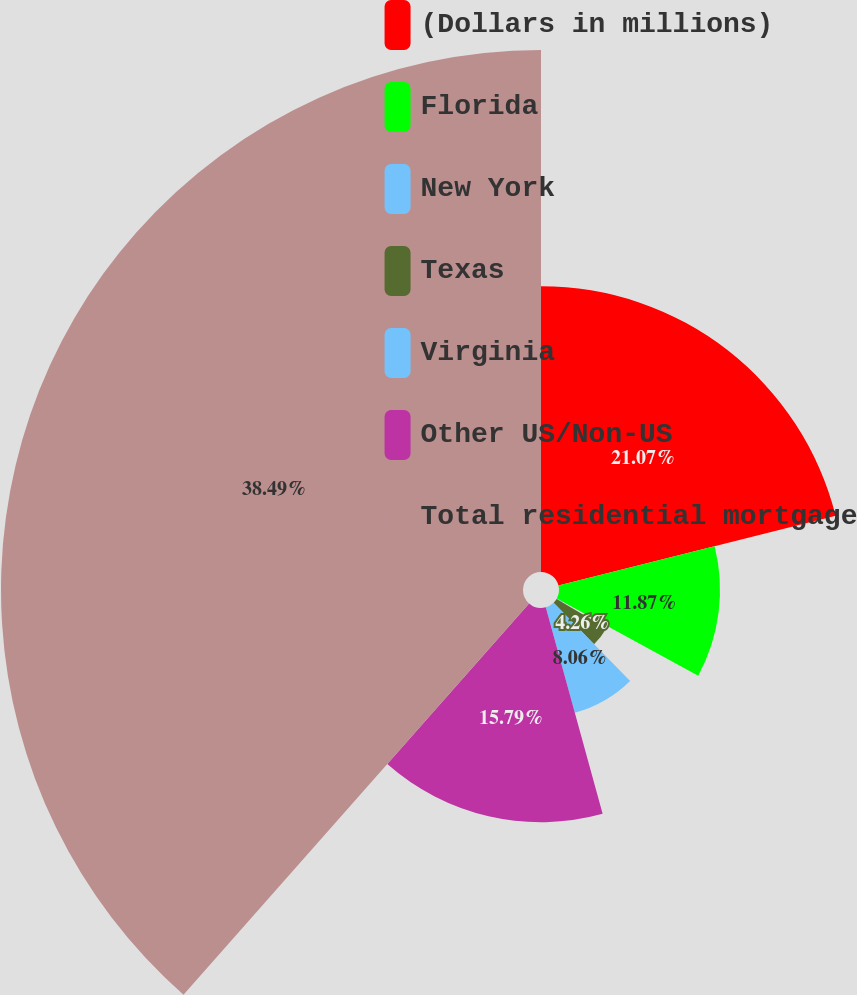<chart> <loc_0><loc_0><loc_500><loc_500><pie_chart><fcel>(Dollars in millions)<fcel>Florida<fcel>New York<fcel>Texas<fcel>Virginia<fcel>Other US/Non-US<fcel>Total residential mortgage<nl><fcel>21.07%<fcel>11.87%<fcel>0.46%<fcel>4.26%<fcel>8.06%<fcel>15.79%<fcel>38.48%<nl></chart> 